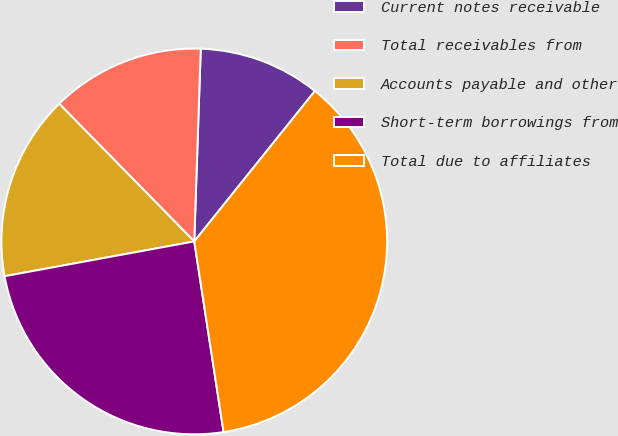<chart> <loc_0><loc_0><loc_500><loc_500><pie_chart><fcel>Current notes receivable<fcel>Total receivables from<fcel>Accounts payable and other<fcel>Short-term borrowings from<fcel>Total due to affiliates<nl><fcel>10.22%<fcel>12.88%<fcel>15.54%<fcel>24.54%<fcel>36.81%<nl></chart> 